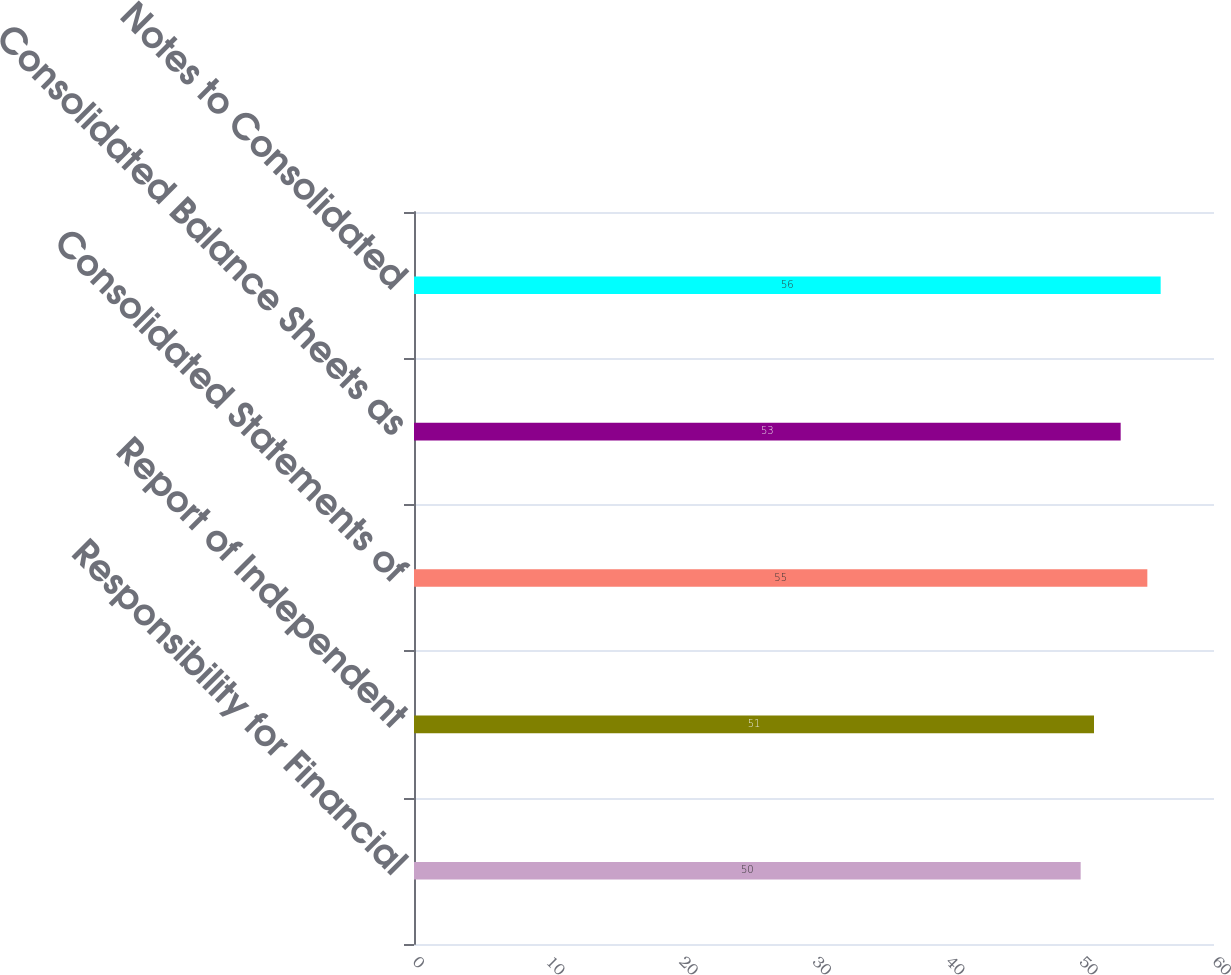Convert chart to OTSL. <chart><loc_0><loc_0><loc_500><loc_500><bar_chart><fcel>Responsibility for Financial<fcel>Report of Independent<fcel>Consolidated Statements of<fcel>Consolidated Balance Sheets as<fcel>Notes to Consolidated<nl><fcel>50<fcel>51<fcel>55<fcel>53<fcel>56<nl></chart> 